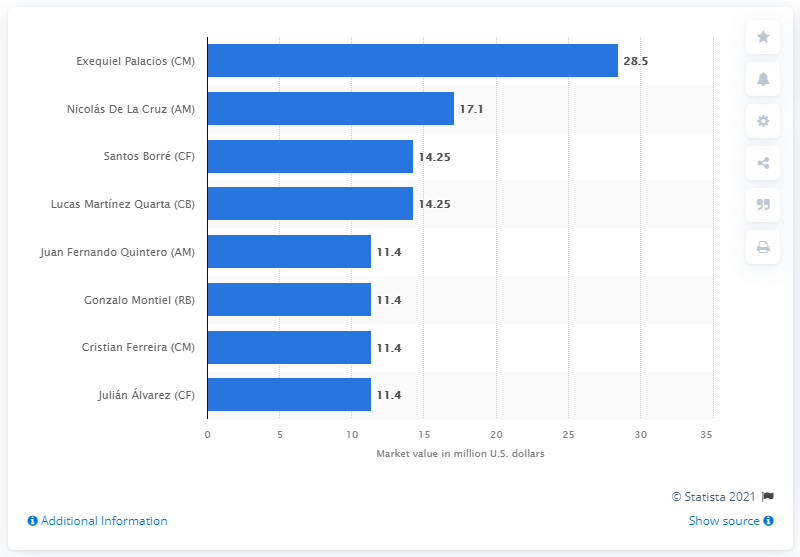Point out several critical features in this image. The market value of Nicolas De La Cruz was 17.1 million dollars. The market value of Exequiel Palacios was 28.5... 